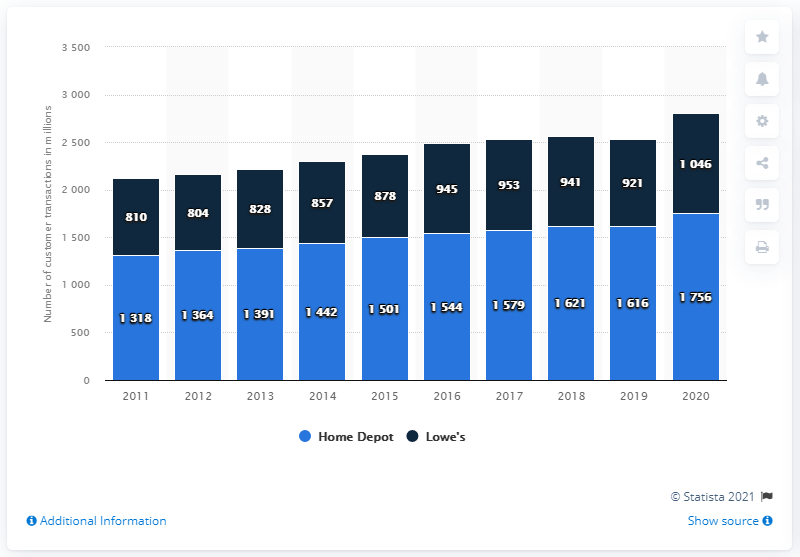Indicate a few pertinent items in this graphic. In 2011, the smallest bar occurred. In the year 2020, the tallest bar occurred. 